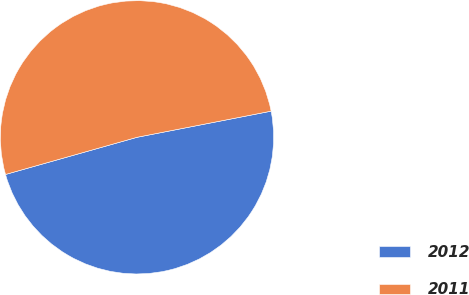Convert chart to OTSL. <chart><loc_0><loc_0><loc_500><loc_500><pie_chart><fcel>2012<fcel>2011<nl><fcel>48.68%<fcel>51.32%<nl></chart> 